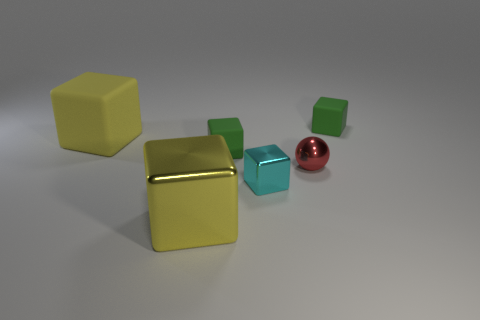Subtract all yellow metal blocks. How many blocks are left? 4 Subtract 1 spheres. How many spheres are left? 0 Subtract all yellow balls. How many cyan blocks are left? 1 Add 2 tiny cyan metal things. How many tiny cyan metal things exist? 3 Add 1 yellow shiny cubes. How many objects exist? 7 Subtract all yellow cubes. How many cubes are left? 3 Subtract 0 gray cylinders. How many objects are left? 6 Subtract all blocks. How many objects are left? 1 Subtract all blue blocks. Subtract all yellow cylinders. How many blocks are left? 5 Subtract all large matte objects. Subtract all yellow things. How many objects are left? 3 